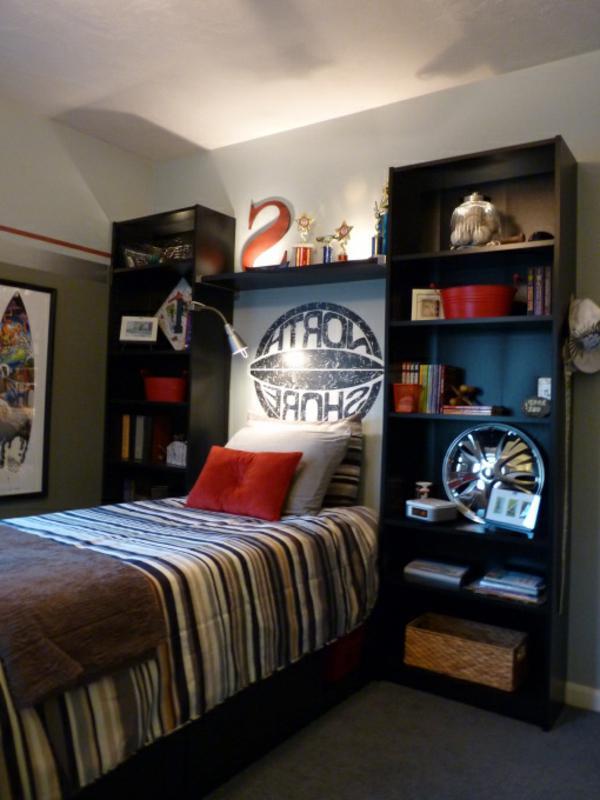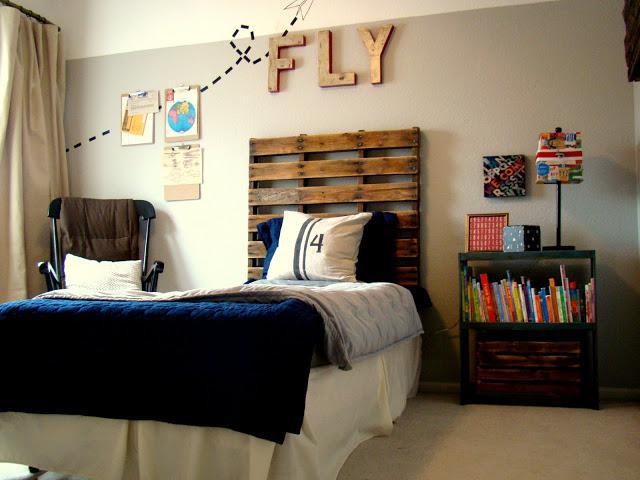The first image is the image on the left, the second image is the image on the right. Analyze the images presented: Is the assertion "None of the beds are bunk beds." valid? Answer yes or no. Yes. The first image is the image on the left, the second image is the image on the right. Examine the images to the left and right. Is the description "AN image shows a bed with a patterned bedspread, flanked by black shelving joined by a top bridge." accurate? Answer yes or no. Yes. 